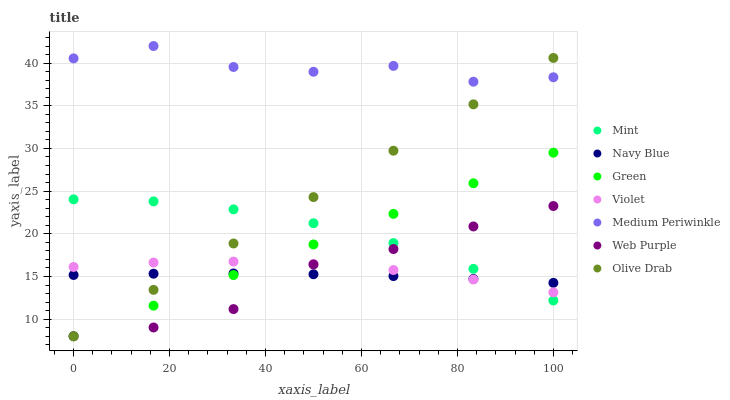Does Navy Blue have the minimum area under the curve?
Answer yes or no. Yes. Does Medium Periwinkle have the maximum area under the curve?
Answer yes or no. Yes. Does Web Purple have the minimum area under the curve?
Answer yes or no. No. Does Web Purple have the maximum area under the curve?
Answer yes or no. No. Is Green the smoothest?
Answer yes or no. Yes. Is Medium Periwinkle the roughest?
Answer yes or no. Yes. Is Web Purple the smoothest?
Answer yes or no. No. Is Web Purple the roughest?
Answer yes or no. No. Does Web Purple have the lowest value?
Answer yes or no. Yes. Does Medium Periwinkle have the lowest value?
Answer yes or no. No. Does Medium Periwinkle have the highest value?
Answer yes or no. Yes. Does Web Purple have the highest value?
Answer yes or no. No. Is Green less than Medium Periwinkle?
Answer yes or no. Yes. Is Medium Periwinkle greater than Mint?
Answer yes or no. Yes. Does Violet intersect Web Purple?
Answer yes or no. Yes. Is Violet less than Web Purple?
Answer yes or no. No. Is Violet greater than Web Purple?
Answer yes or no. No. Does Green intersect Medium Periwinkle?
Answer yes or no. No. 